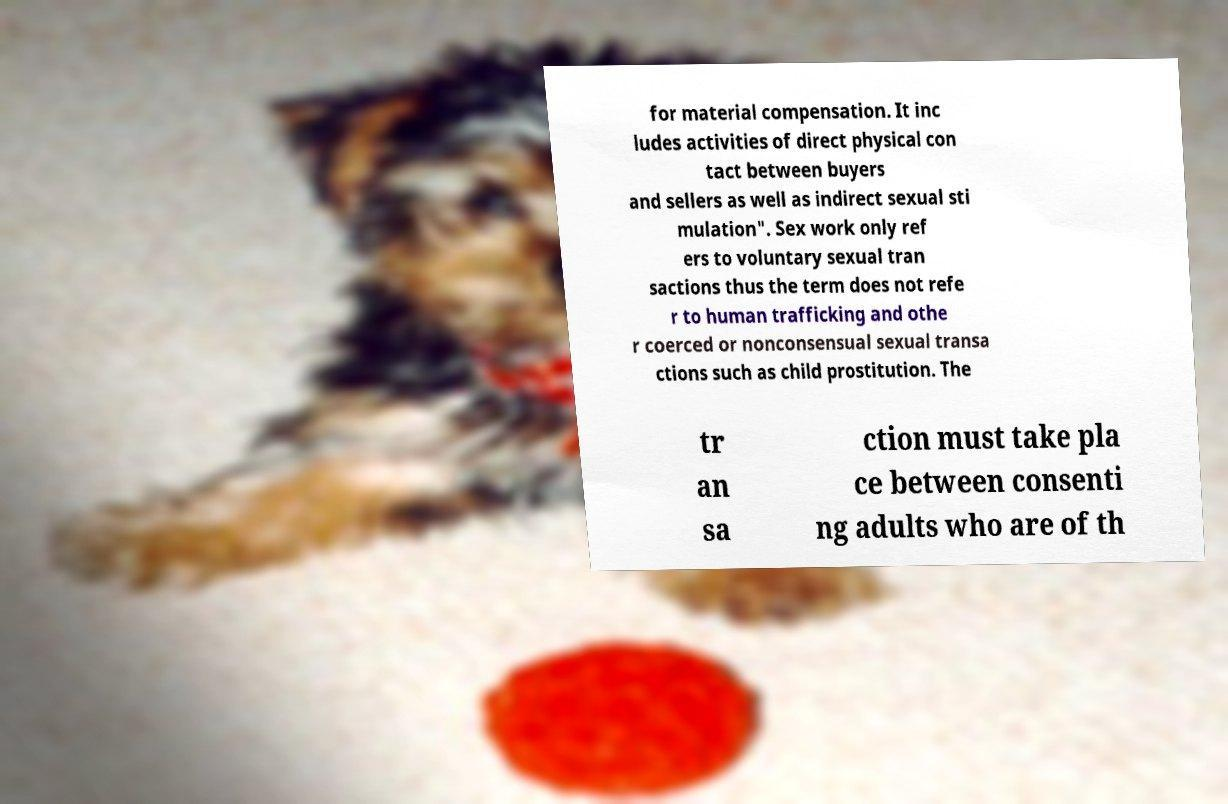Can you read and provide the text displayed in the image?This photo seems to have some interesting text. Can you extract and type it out for me? for material compensation. It inc ludes activities of direct physical con tact between buyers and sellers as well as indirect sexual sti mulation". Sex work only ref ers to voluntary sexual tran sactions thus the term does not refe r to human trafficking and othe r coerced or nonconsensual sexual transa ctions such as child prostitution. The tr an sa ction must take pla ce between consenti ng adults who are of th 